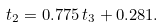<formula> <loc_0><loc_0><loc_500><loc_500>t _ { 2 } = 0 . 7 7 5 \, t _ { 3 } + 0 . 2 8 1 .</formula> 